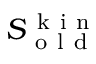Convert formula to latex. <formula><loc_0><loc_0><loc_500><loc_500>S _ { o l d } ^ { k i n }</formula> 